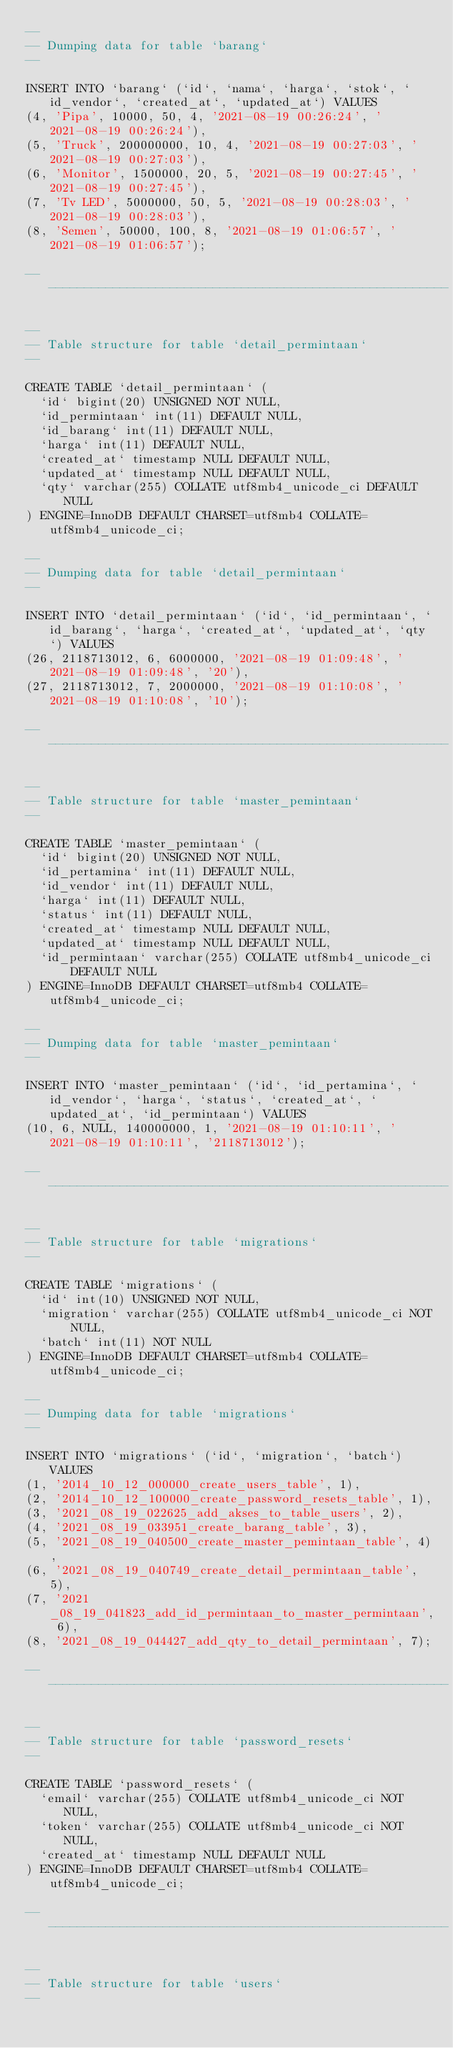<code> <loc_0><loc_0><loc_500><loc_500><_SQL_>--
-- Dumping data for table `barang`
--

INSERT INTO `barang` (`id`, `nama`, `harga`, `stok`, `id_vendor`, `created_at`, `updated_at`) VALUES
(4, 'Pipa', 10000, 50, 4, '2021-08-19 00:26:24', '2021-08-19 00:26:24'),
(5, 'Truck', 200000000, 10, 4, '2021-08-19 00:27:03', '2021-08-19 00:27:03'),
(6, 'Monitor', 1500000, 20, 5, '2021-08-19 00:27:45', '2021-08-19 00:27:45'),
(7, 'Tv LED', 5000000, 50, 5, '2021-08-19 00:28:03', '2021-08-19 00:28:03'),
(8, 'Semen', 50000, 100, 8, '2021-08-19 01:06:57', '2021-08-19 01:06:57');

-- --------------------------------------------------------

--
-- Table structure for table `detail_permintaan`
--

CREATE TABLE `detail_permintaan` (
  `id` bigint(20) UNSIGNED NOT NULL,
  `id_permintaan` int(11) DEFAULT NULL,
  `id_barang` int(11) DEFAULT NULL,
  `harga` int(11) DEFAULT NULL,
  `created_at` timestamp NULL DEFAULT NULL,
  `updated_at` timestamp NULL DEFAULT NULL,
  `qty` varchar(255) COLLATE utf8mb4_unicode_ci DEFAULT NULL
) ENGINE=InnoDB DEFAULT CHARSET=utf8mb4 COLLATE=utf8mb4_unicode_ci;

--
-- Dumping data for table `detail_permintaan`
--

INSERT INTO `detail_permintaan` (`id`, `id_permintaan`, `id_barang`, `harga`, `created_at`, `updated_at`, `qty`) VALUES
(26, 2118713012, 6, 6000000, '2021-08-19 01:09:48', '2021-08-19 01:09:48', '20'),
(27, 2118713012, 7, 2000000, '2021-08-19 01:10:08', '2021-08-19 01:10:08', '10');

-- --------------------------------------------------------

--
-- Table structure for table `master_pemintaan`
--

CREATE TABLE `master_pemintaan` (
  `id` bigint(20) UNSIGNED NOT NULL,
  `id_pertamina` int(11) DEFAULT NULL,
  `id_vendor` int(11) DEFAULT NULL,
  `harga` int(11) DEFAULT NULL,
  `status` int(11) DEFAULT NULL,
  `created_at` timestamp NULL DEFAULT NULL,
  `updated_at` timestamp NULL DEFAULT NULL,
  `id_permintaan` varchar(255) COLLATE utf8mb4_unicode_ci DEFAULT NULL
) ENGINE=InnoDB DEFAULT CHARSET=utf8mb4 COLLATE=utf8mb4_unicode_ci;

--
-- Dumping data for table `master_pemintaan`
--

INSERT INTO `master_pemintaan` (`id`, `id_pertamina`, `id_vendor`, `harga`, `status`, `created_at`, `updated_at`, `id_permintaan`) VALUES
(10, 6, NULL, 140000000, 1, '2021-08-19 01:10:11', '2021-08-19 01:10:11', '2118713012');

-- --------------------------------------------------------

--
-- Table structure for table `migrations`
--

CREATE TABLE `migrations` (
  `id` int(10) UNSIGNED NOT NULL,
  `migration` varchar(255) COLLATE utf8mb4_unicode_ci NOT NULL,
  `batch` int(11) NOT NULL
) ENGINE=InnoDB DEFAULT CHARSET=utf8mb4 COLLATE=utf8mb4_unicode_ci;

--
-- Dumping data for table `migrations`
--

INSERT INTO `migrations` (`id`, `migration`, `batch`) VALUES
(1, '2014_10_12_000000_create_users_table', 1),
(2, '2014_10_12_100000_create_password_resets_table', 1),
(3, '2021_08_19_022625_add_akses_to_table_users', 2),
(4, '2021_08_19_033951_create_barang_table', 3),
(5, '2021_08_19_040500_create_master_pemintaan_table', 4),
(6, '2021_08_19_040749_create_detail_permintaan_table', 5),
(7, '2021_08_19_041823_add_id_permintaan_to_master_permintaan', 6),
(8, '2021_08_19_044427_add_qty_to_detail_permintaan', 7);

-- --------------------------------------------------------

--
-- Table structure for table `password_resets`
--

CREATE TABLE `password_resets` (
  `email` varchar(255) COLLATE utf8mb4_unicode_ci NOT NULL,
  `token` varchar(255) COLLATE utf8mb4_unicode_ci NOT NULL,
  `created_at` timestamp NULL DEFAULT NULL
) ENGINE=InnoDB DEFAULT CHARSET=utf8mb4 COLLATE=utf8mb4_unicode_ci;

-- --------------------------------------------------------

--
-- Table structure for table `users`
--
</code> 